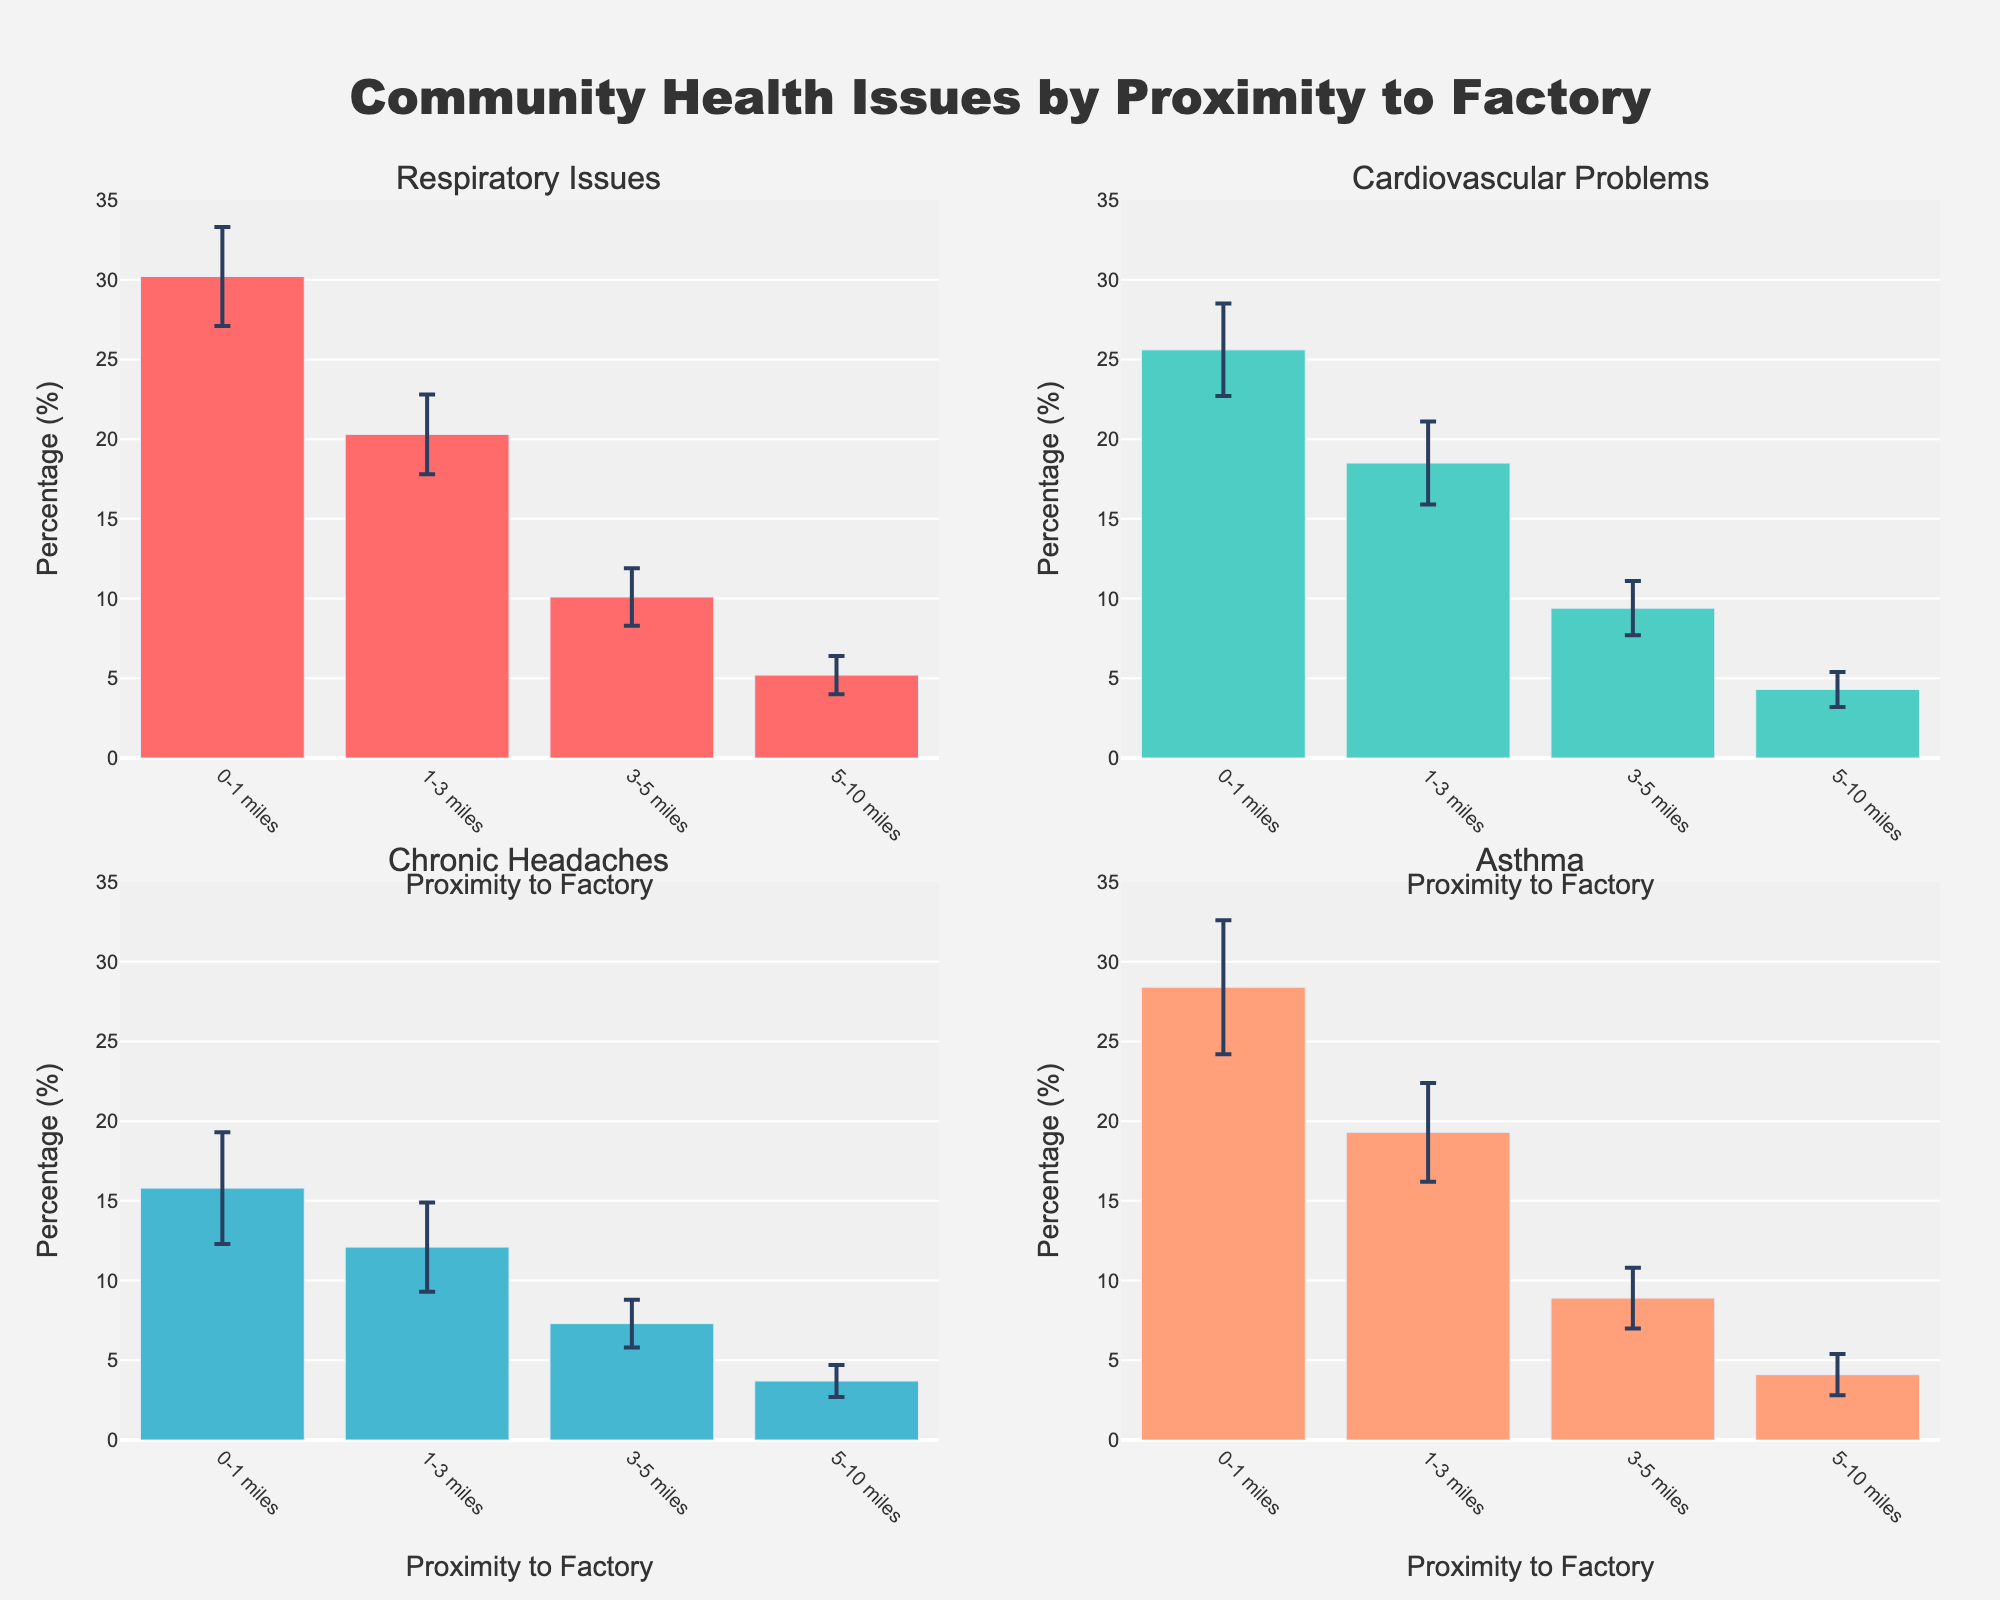What is the title of the figure? The title of the figure is displayed at the top center and provides an overview of what the figure represents.
Answer: Community Health Issues by Proximity to Factory Which health issue appears most frequently in the 0-1 miles range? To find the most frequent health issue, compare the mean percentages of all health issues in the 0-1 miles range.
Answer: Respiratory Issues What is the range of percentages shown on the y-axis across the subplots? The y-axis in each subplot ranges from the minimum value to the maximum value shown, which can be identified by examining the axis labels.
Answer: 0 to 35 Which proximity range shows the highest mean percentage for Cardiovascular Problems? By examining the Cardiovascular Problems subplot, compare the values of each bar and identify which proximity range has the highest value.
Answer: 0-1 miles How do the error margins for Respiratory Issues in the 0-1 miles range compare to those in the 3-5 miles range? Compare the error bars in both the 0-1 miles and 3-5 miles categories for Respiratory Issues.
Answer: Larger in 0-1 miles What is the difference between the mean percentage of Asthma in the 0-1 miles range and the 5-10 miles range? Subtract the mean percentage of Asthma in the 5-10 miles range from the mean percentage in the 0-1 miles range.
Answer: 24.3% Which health issue shows the smallest mean percentage in the 1-3 miles range? In the subplot for the 1-3 miles range, compare the mean percentages of all health issues and identify the smallest one.
Answer: Chronic Headaches What can be inferred about health issues and their proximity to the factory based on the subplots? By examining trends across the subplots for each health issue, analyze how the mean percentages change with increasing distance from the factory. Note that closer proximities generally have higher percentages, indicating a potential correlation between proximity to the factory and higher incidence of health issues.
Answer: Higher health issues closer to the factory Which health issue has the highest error margin in any proximity range, and what is that value? By comparing the error margins for all health issues in all proximity ranges, identify the largest one.
Answer: Asthma in 0-1 miles, 4.2% How do Chronic Headaches at 0-1 miles compare across the four proximity ranges? Compare the mean percentages of Chronic Headaches across all proximity ranges to see how they change with distance.
Answer: Highest at 0-1 miles and decreases with distance 